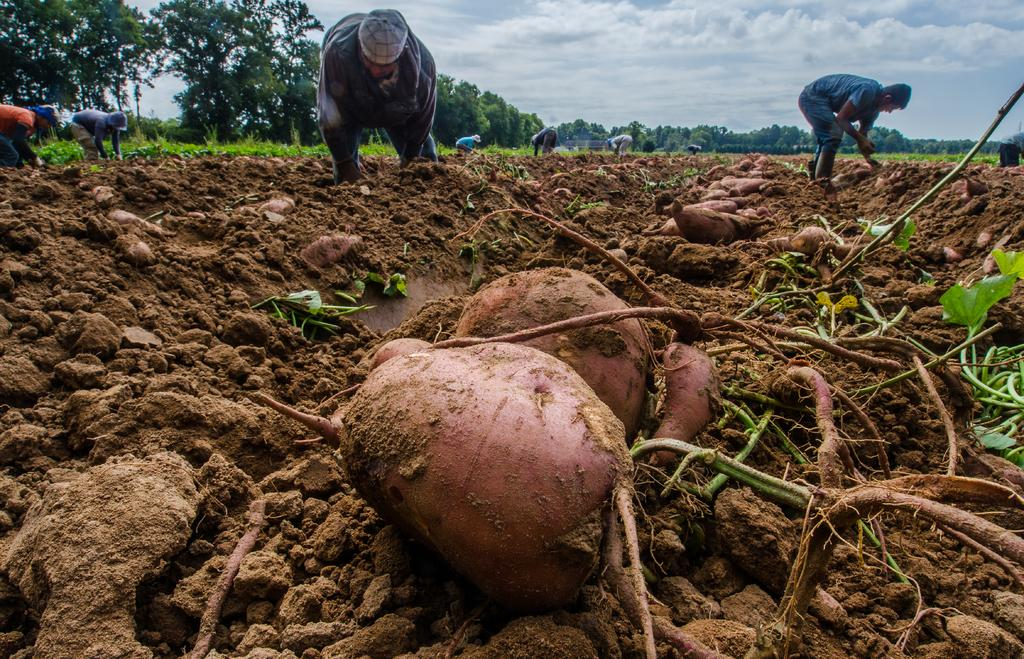What type of food is present in the image? There are sweet potatoes in the image. What are the people in the image doing? People are digging in the image. What can be seen in the background of the image? There are trees at the back of the image. How much profit did the yak make from the sweet potatoes in the image? There is no yak or mention of profit in the image; it only shows sweet potatoes and people digging. 